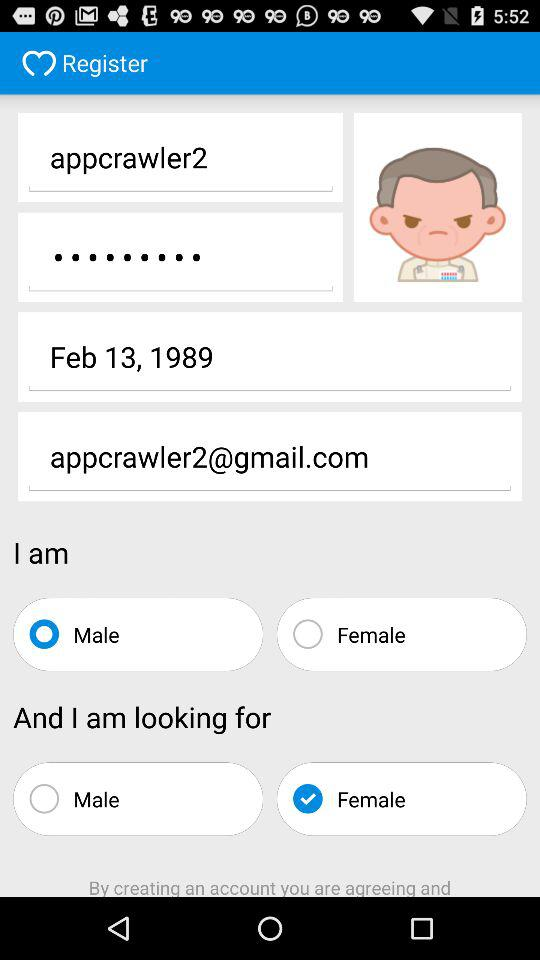For which gender user is looking for? The user is looking for the female gender. 